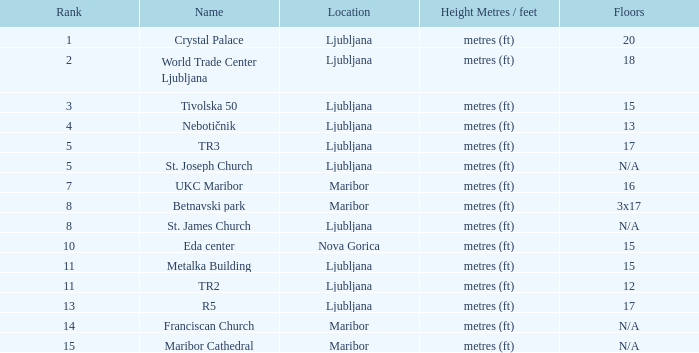What height in metres/feet has a ranking of 8 and consists of 3x17 floors? Metres (ft). 